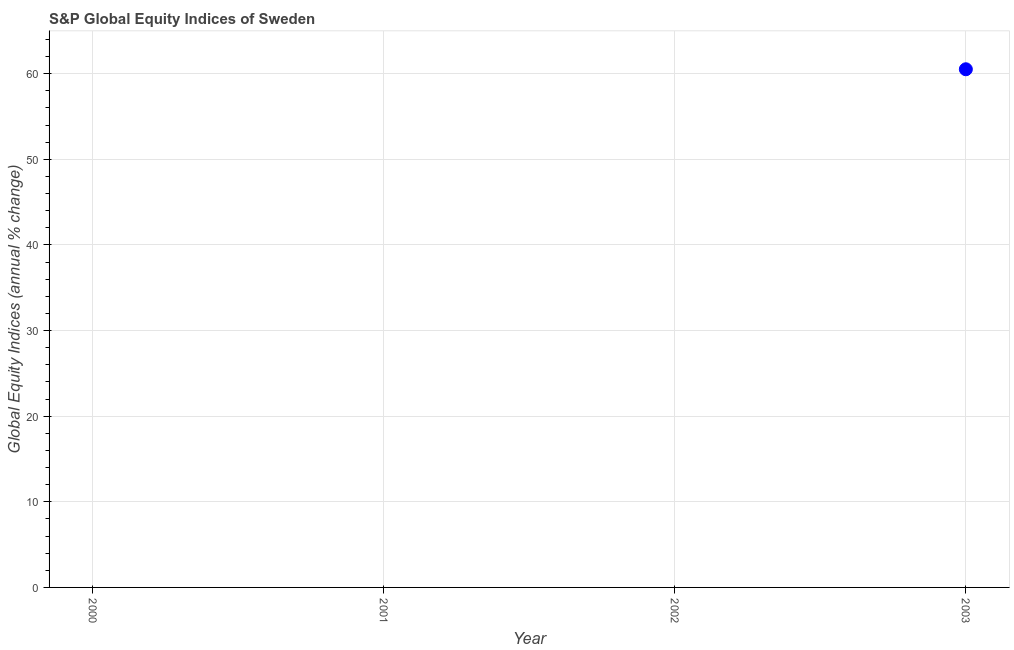Across all years, what is the maximum s&p global equity indices?
Provide a short and direct response. 60.51. Across all years, what is the minimum s&p global equity indices?
Your answer should be very brief. 0. What is the sum of the s&p global equity indices?
Keep it short and to the point. 60.51. What is the average s&p global equity indices per year?
Make the answer very short. 15.13. What is the difference between the highest and the lowest s&p global equity indices?
Offer a terse response. 60.51. How many dotlines are there?
Offer a very short reply. 1. How many years are there in the graph?
Keep it short and to the point. 4. Are the values on the major ticks of Y-axis written in scientific E-notation?
Your response must be concise. No. Does the graph contain any zero values?
Your answer should be very brief. Yes. Does the graph contain grids?
Offer a very short reply. Yes. What is the title of the graph?
Provide a short and direct response. S&P Global Equity Indices of Sweden. What is the label or title of the Y-axis?
Your answer should be compact. Global Equity Indices (annual % change). What is the Global Equity Indices (annual % change) in 2001?
Your answer should be very brief. 0. What is the Global Equity Indices (annual % change) in 2003?
Provide a succinct answer. 60.51. 